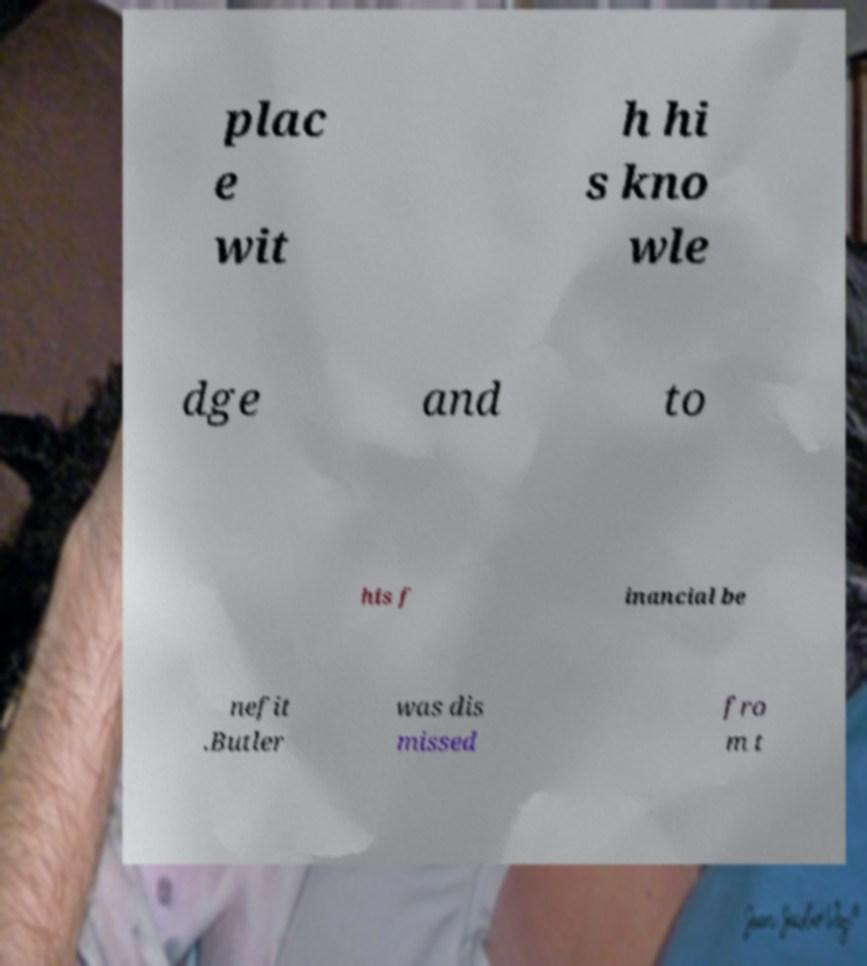I need the written content from this picture converted into text. Can you do that? plac e wit h hi s kno wle dge and to his f inancial be nefit .Butler was dis missed fro m t 